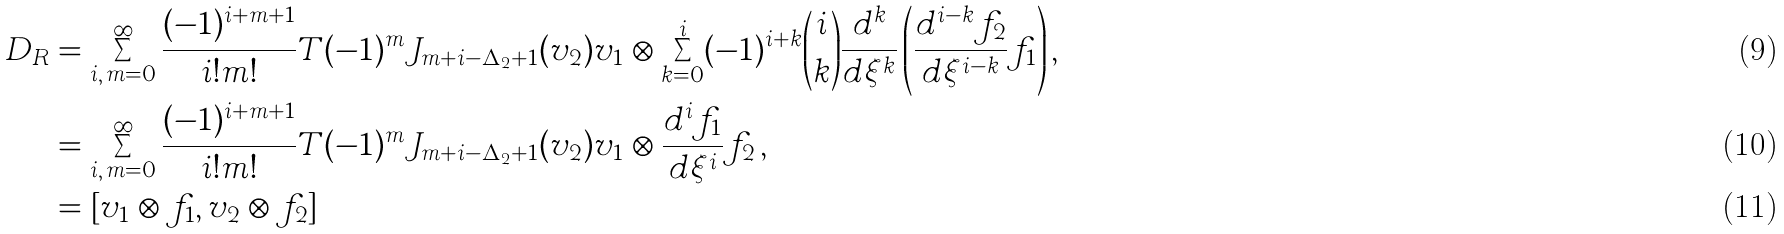Convert formula to latex. <formula><loc_0><loc_0><loc_500><loc_500>D _ { R } & = \sum _ { i , \, m = 0 } ^ { \infty } \frac { ( - 1 ) ^ { i + m + 1 } } { i ! m ! } T ( - 1 ) ^ { m } J _ { m + i - \Delta _ { 2 } + 1 } ( v _ { 2 } ) v _ { 1 } \otimes \sum _ { k = 0 } ^ { i } ( - 1 ) ^ { i + k } \binom { i } { k } \frac { d ^ { k } } { d \xi ^ { k } } \left ( \frac { d ^ { i - k } f _ { 2 } } { d \xi ^ { i - k } } f _ { 1 } \right ) , \\ & = \sum _ { i , \, m = 0 } ^ { \infty } \frac { ( - 1 ) ^ { i + m + 1 } } { i ! m ! } T ( - 1 ) ^ { m } J _ { m + i - \Delta _ { 2 } + 1 } ( v _ { 2 } ) v _ { 1 } \otimes \frac { d ^ { i } f _ { 1 } } { d \xi ^ { i } } f _ { 2 } \, , \\ & = [ v _ { 1 } \otimes f _ { 1 } , v _ { 2 } \otimes f _ { 2 } ]</formula> 